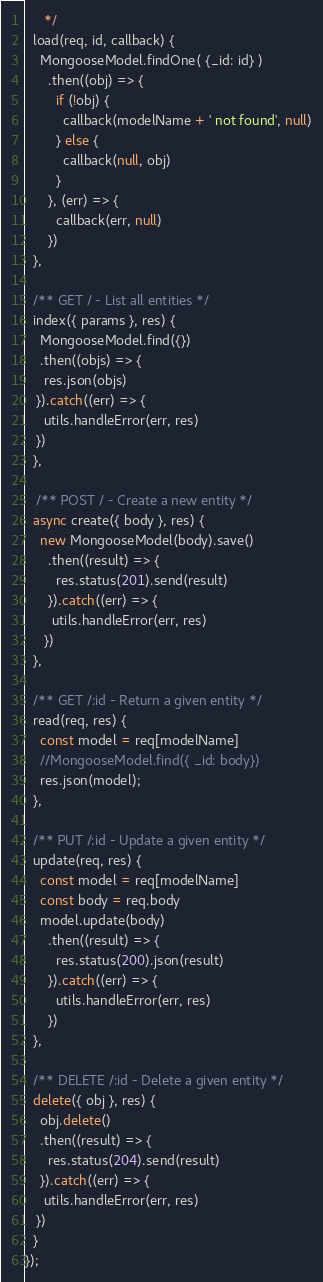Convert code to text. <code><loc_0><loc_0><loc_500><loc_500><_JavaScript_>	 */
  load(req, id, callback) {
    MongooseModel.findOne( {_id: id} )
      .then((obj) => {
        if (!obj) {
          callback(modelName + ' not found', null)
        } else {
          callback(null, obj)
        }
      }, (err) => {
        callback(err, null)
      })
  },

  /** GET / - List all entities */
  index({ params }, res) {
    MongooseModel.find({})
    .then((objs) => {
     res.json(objs)
   }).catch((err) => {
     utils.handleError(err, res)
   })
  },

   /** POST / - Create a new entity */
  async create({ body }, res) {
    new MongooseModel(body).save()
      .then((result) => {
        res.status(201).send(result)
      }).catch((err) => {
       utils.handleError(err, res)
     })
  },

  /** GET /:id - Return a given entity */
  read(req, res) {
    const model = req[modelName]
    //MongooseModel.find({ _id: body})
    res.json(model);
  },

  /** PUT /:id - Update a given entity */
  update(req, res) {
    const model = req[modelName]
    const body = req.body
    model.update(body)
      .then((result) => {
        res.status(200).json(result)
      }).catch((err) => {
        utils.handleError(err, res)
      })
  },

  /** DELETE /:id - Delete a given entity */
  delete({ obj }, res) {
    obj.delete()
    .then((result) => {
      res.status(204).send(result)
    }).catch((err) => {
     utils.handleError(err, res)
   })
  }
});
</code> 